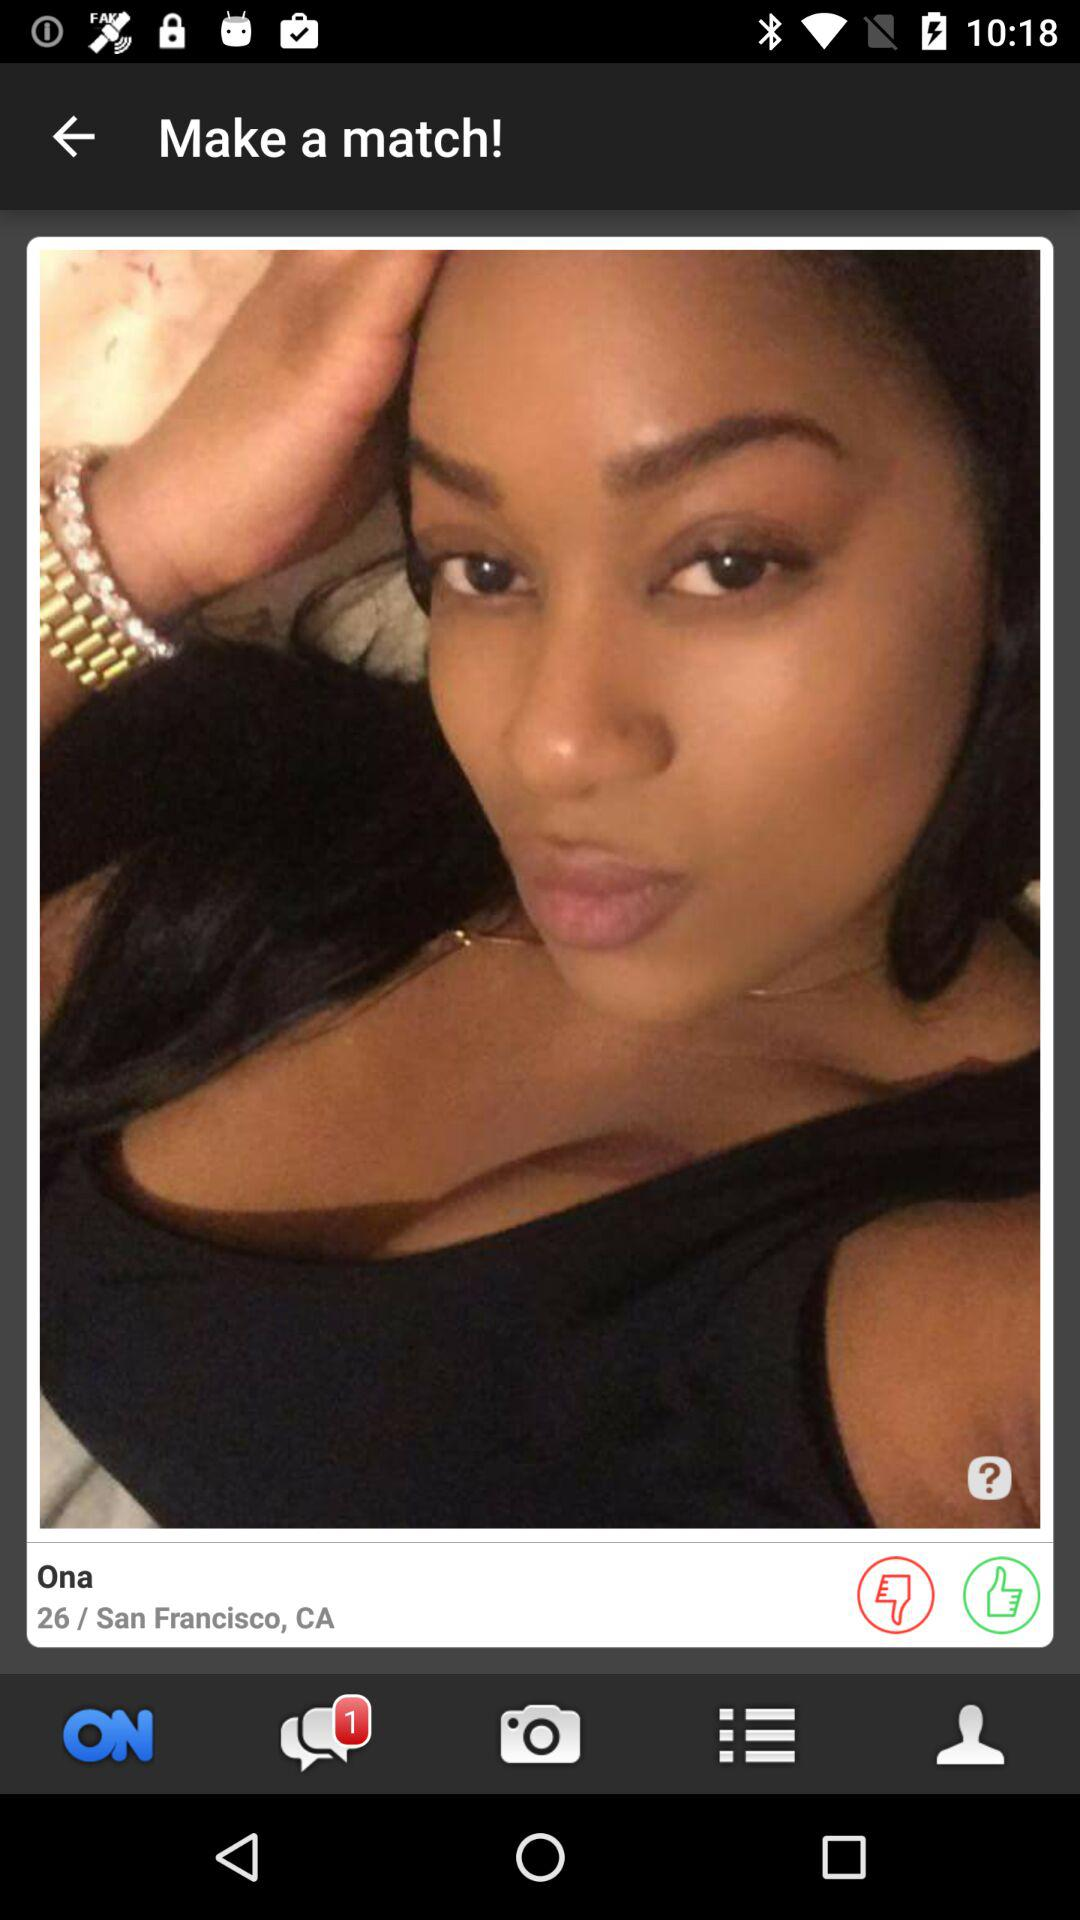What is the number of unread chats? The number of unread chats is 1. 